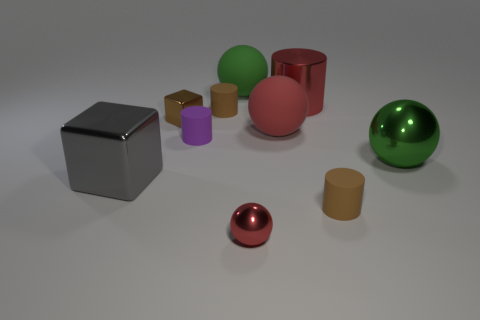Subtract all big metallic spheres. How many spheres are left? 3 Subtract all red cylinders. How many cylinders are left? 3 Subtract all blue blocks. How many brown cylinders are left? 2 Subtract all cylinders. How many objects are left? 6 Subtract all big green metallic objects. Subtract all small yellow matte cylinders. How many objects are left? 9 Add 1 red metallic objects. How many red metallic objects are left? 3 Add 2 large green spheres. How many large green spheres exist? 4 Subtract 1 gray cubes. How many objects are left? 9 Subtract 1 cylinders. How many cylinders are left? 3 Subtract all purple spheres. Subtract all blue blocks. How many spheres are left? 4 